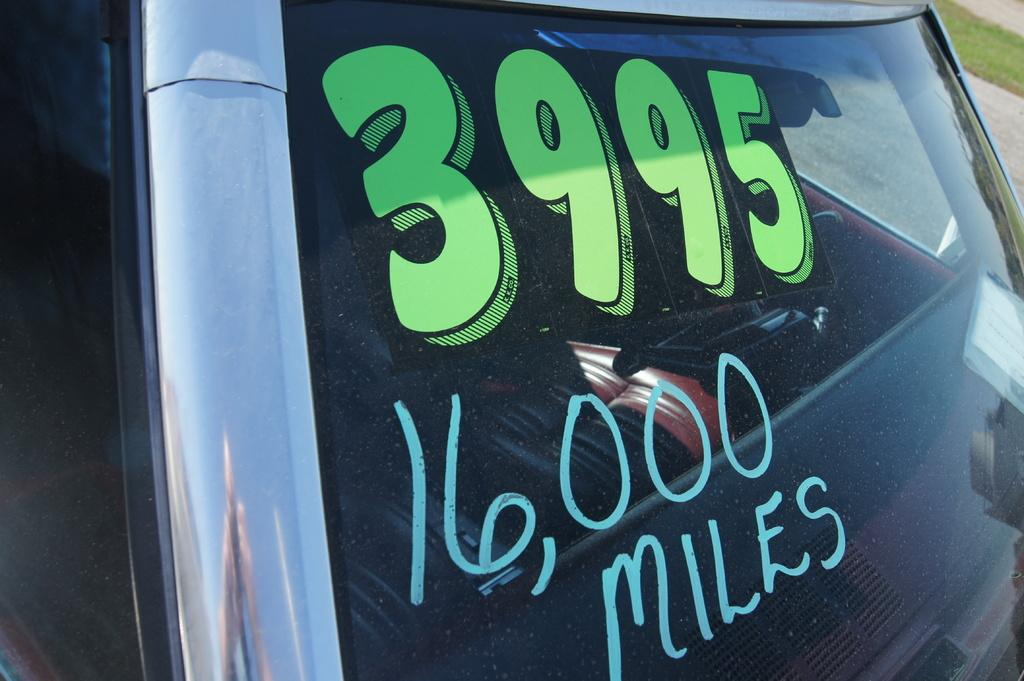What is written or displayed on the transparent glass of the vehicle in the image? There are numbers and a word on the transparent glass of the vehicle. What type of surface can be seen in the background of the image? There is grass visible in the image. What type of mint plant can be seen growing on the arm of the person in the image? There is no person or mint plant present in the image. 